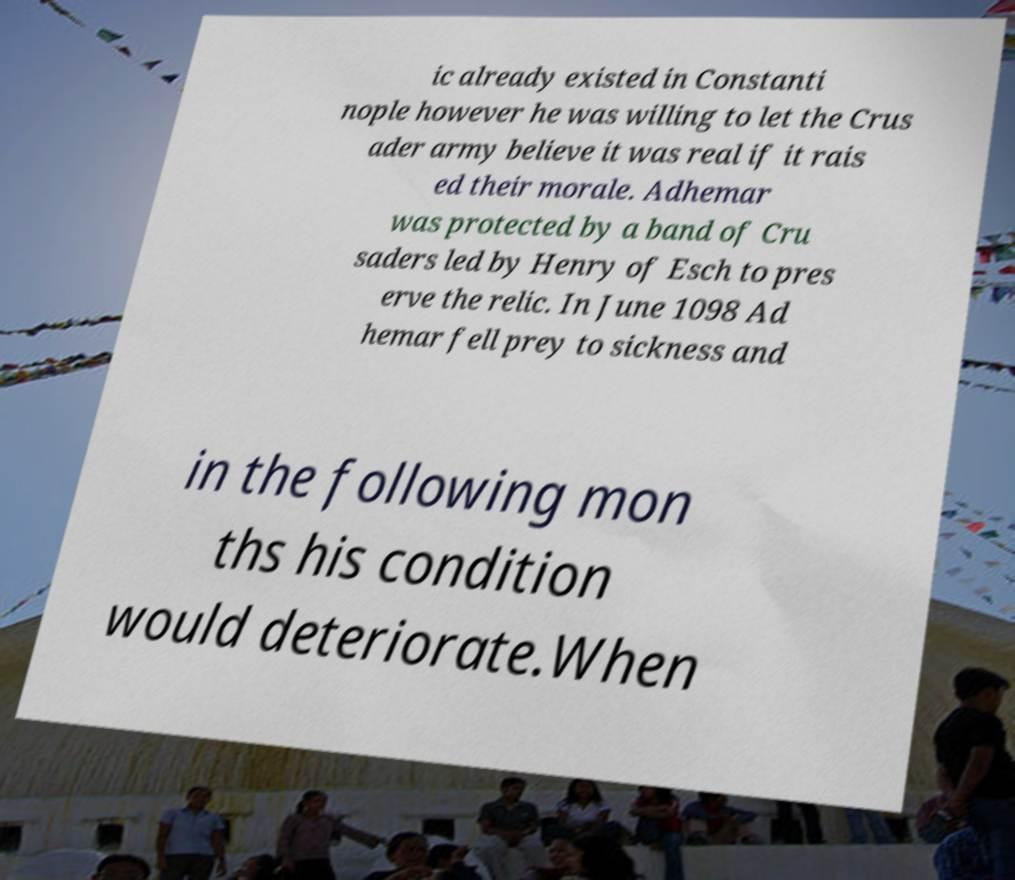For documentation purposes, I need the text within this image transcribed. Could you provide that? ic already existed in Constanti nople however he was willing to let the Crus ader army believe it was real if it rais ed their morale. Adhemar was protected by a band of Cru saders led by Henry of Esch to pres erve the relic. In June 1098 Ad hemar fell prey to sickness and in the following mon ths his condition would deteriorate.When 